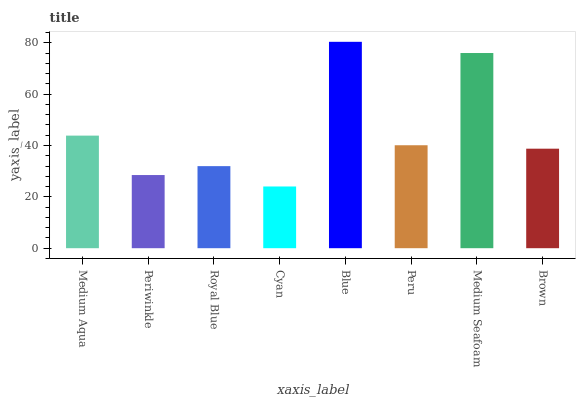Is Periwinkle the minimum?
Answer yes or no. No. Is Periwinkle the maximum?
Answer yes or no. No. Is Medium Aqua greater than Periwinkle?
Answer yes or no. Yes. Is Periwinkle less than Medium Aqua?
Answer yes or no. Yes. Is Periwinkle greater than Medium Aqua?
Answer yes or no. No. Is Medium Aqua less than Periwinkle?
Answer yes or no. No. Is Peru the high median?
Answer yes or no. Yes. Is Brown the low median?
Answer yes or no. Yes. Is Periwinkle the high median?
Answer yes or no. No. Is Blue the low median?
Answer yes or no. No. 